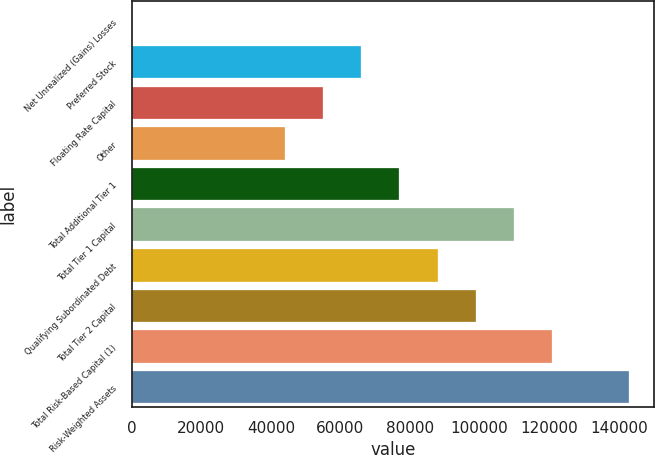<chart> <loc_0><loc_0><loc_500><loc_500><bar_chart><fcel>Net Unrealized (Gains) Losses<fcel>Preferred Stock<fcel>Floating Rate Capital<fcel>Other<fcel>Total Additional Tier 1<fcel>Total Tier 1 Capital<fcel>Qualifying Subordinated Debt<fcel>Total Tier 2 Capital<fcel>Total Risk-Based Capital (1)<fcel>Risk-Weighted Assets<nl><fcel>3.8<fcel>65969.4<fcel>54975.2<fcel>43980.9<fcel>76963.7<fcel>109946<fcel>87958<fcel>98952.2<fcel>120941<fcel>142929<nl></chart> 